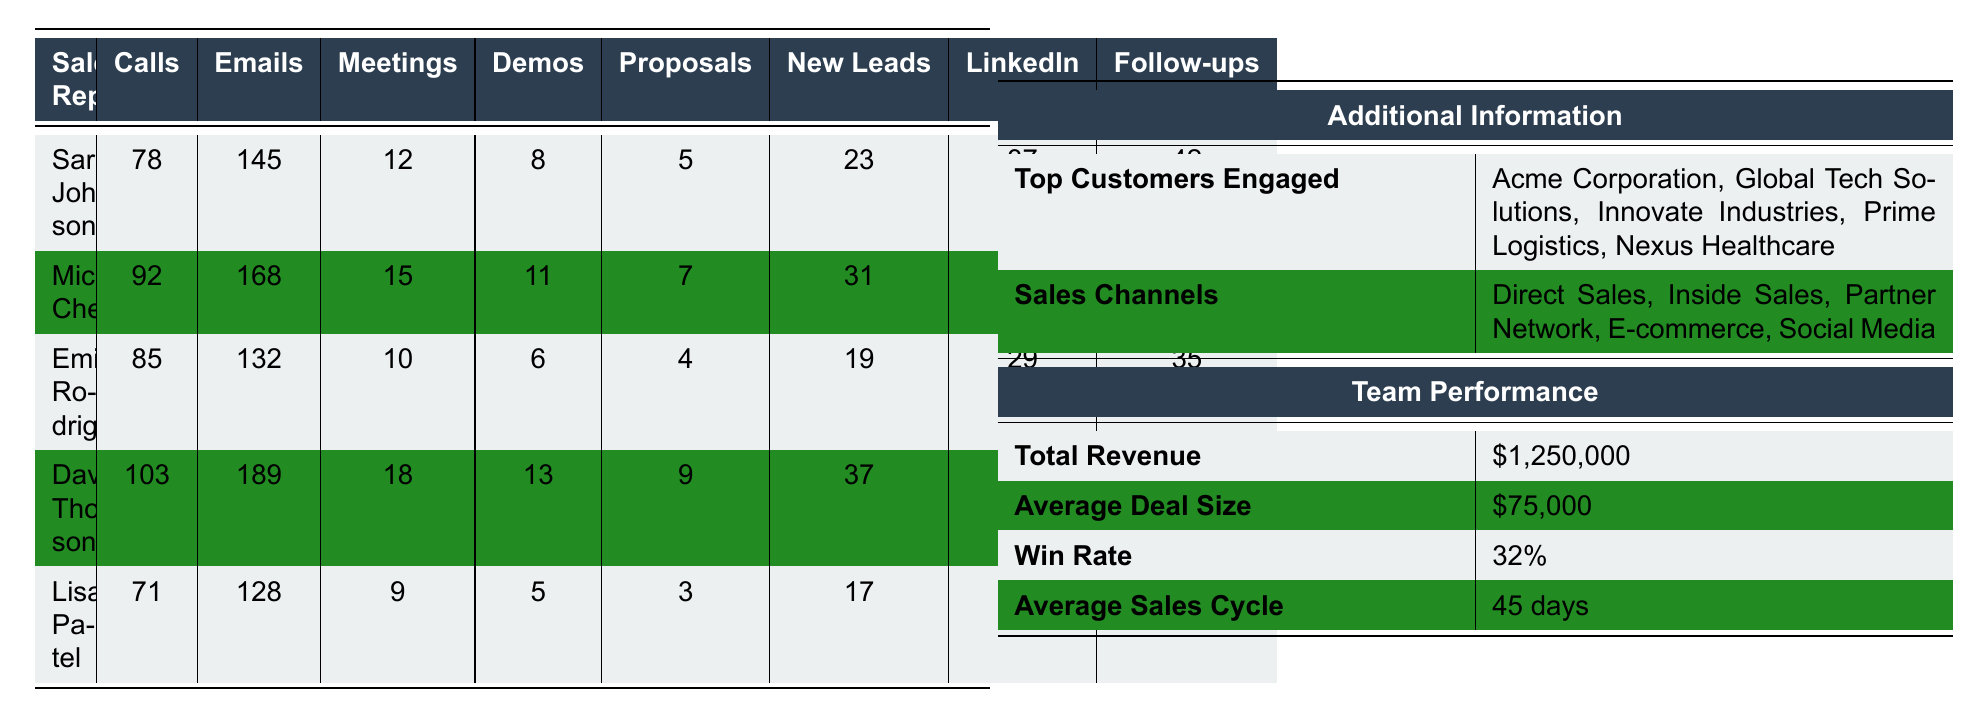What is the total number of calls made by the sales force? To find the total calls made, sum the calls of each sales rep: 78 + 92 + 85 + 103 + 71 = 429.
Answer: 429 Which sales rep scheduled the most meetings? David Thompson scheduled the most meetings with 18, as it is higher than the other reps' meetings.
Answer: David Thompson What percentage of the deals won by the sales force came from the average deal size? The win rate is 32%, meaning that 32% of potential deals are won. Average deal size is $75,000, so the revenue from won deals would be 0.32 * $1,250,000 = $400,000.
Answer: 32% Who generated the most new leads? Michael Chen generated the most new leads with 31, which is higher than the others.
Answer: Michael Chen What is the average number of emails sent by the sales reps? There are 5 sales reps, total emails sent is 145 + 168 + 132 + 189 + 128 = 762. The average is 762 / 5 = 152.4.
Answer: 152.4 Is it true that Lisa Patel had more demos given than Sarah Johnson? Sarah Johnson gave 8 demos, while Lisa Patel gave 5. Therefore, the statement is false.
Answer: No What is the difference in new leads generated between the highest and lowest sales reps? The highest is David Thompson (37 new leads), and the lowest is Lisa Patel (17 new leads). The difference is 37 - 17 = 20.
Answer: 20 Which sales channel does not appear in the table? The sales channels listed are Direct Sales, Inside Sales, Partner Network, E-commerce, and Social Media. All are represented, so the answer is any channel not mentioned.
Answer: N/A What is the total follow-ups made by the sales team? To find the total follow-ups, sum the follow-ups of each sales rep: 42 + 38 + 35 + 49 + 31 = 225.
Answer: 225 Who has the highest win rate, if compared amongst average sales cycles? Since the data gives only one win rate (32%) for the whole team, there’s no comparative win rate for the reps individually in the provided table.
Answer: N/A 